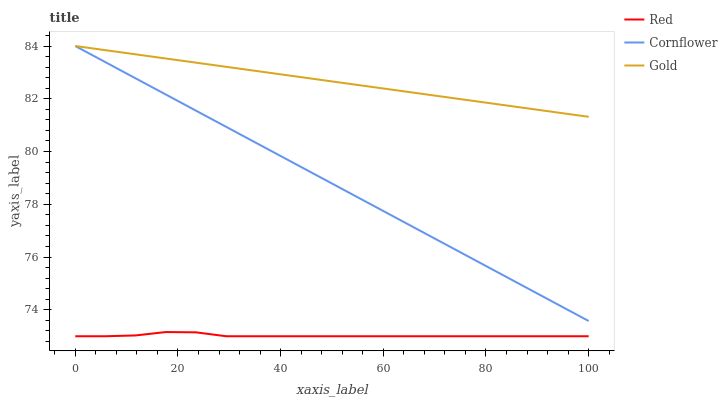Does Red have the minimum area under the curve?
Answer yes or no. Yes. Does Gold have the maximum area under the curve?
Answer yes or no. Yes. Does Gold have the minimum area under the curve?
Answer yes or no. No. Does Red have the maximum area under the curve?
Answer yes or no. No. Is Gold the smoothest?
Answer yes or no. Yes. Is Red the roughest?
Answer yes or no. Yes. Is Red the smoothest?
Answer yes or no. No. Is Gold the roughest?
Answer yes or no. No. Does Red have the lowest value?
Answer yes or no. Yes. Does Gold have the lowest value?
Answer yes or no. No. Does Gold have the highest value?
Answer yes or no. Yes. Does Red have the highest value?
Answer yes or no. No. Is Red less than Gold?
Answer yes or no. Yes. Is Gold greater than Red?
Answer yes or no. Yes. Does Gold intersect Cornflower?
Answer yes or no. Yes. Is Gold less than Cornflower?
Answer yes or no. No. Is Gold greater than Cornflower?
Answer yes or no. No. Does Red intersect Gold?
Answer yes or no. No. 